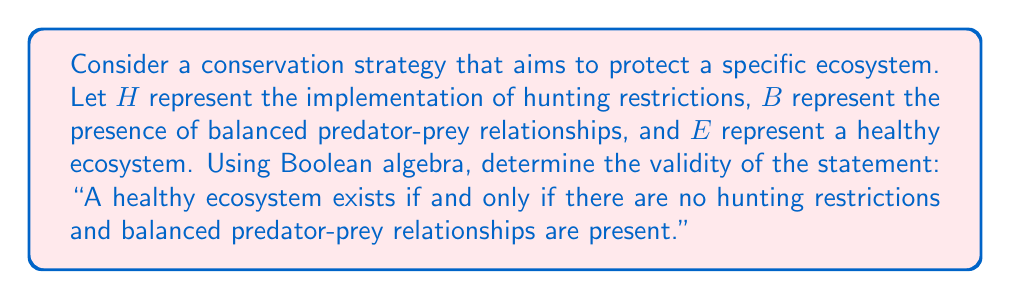What is the answer to this math problem? Let's approach this step-by-step using Boolean algebra:

1) First, we need to translate the given statement into a Boolean expression:
   $E \Leftrightarrow (\neg H \wedge B)$

2) To assess the validity of this statement, we need to create a truth table:

   $H$ | $B$ | $\neg H$ | $\neg H \wedge B$ | $E \Leftrightarrow (\neg H \wedge B)$
   --- | --- | -------- | ----------------- | ----------------------------------
    0  |  0  |    1     |         0         |                 0
    0  |  1  |    1     |         1         |                 1
    1  |  0  |    0     |         0         |                 1
    1  |  1  |    0     |         0         |                 1

3) For the statement to be valid, the last column should all be 1's. However, we see that it's not the case.

4) The first row shows a scenario where there are no hunting restrictions ($H=0$) and no balanced predator-prey relationships ($B=0$), yet the statement suggests this is not a healthy ecosystem ($E=0$).

5) The last two rows show scenarios where hunting restrictions are in place ($H=1$), and the statement suggests these could still be healthy ecosystems ($E=1$), contradicting the original claim.

6) Only the second row fully satisfies the conditions of the statement.

7) From a biological perspective, this aligns with the argument that hunting restrictions might have negative ecological impacts, as the truth table shows scenarios where ecosystems can be healthy with hunting (rows 3 and 4).
Answer: False 